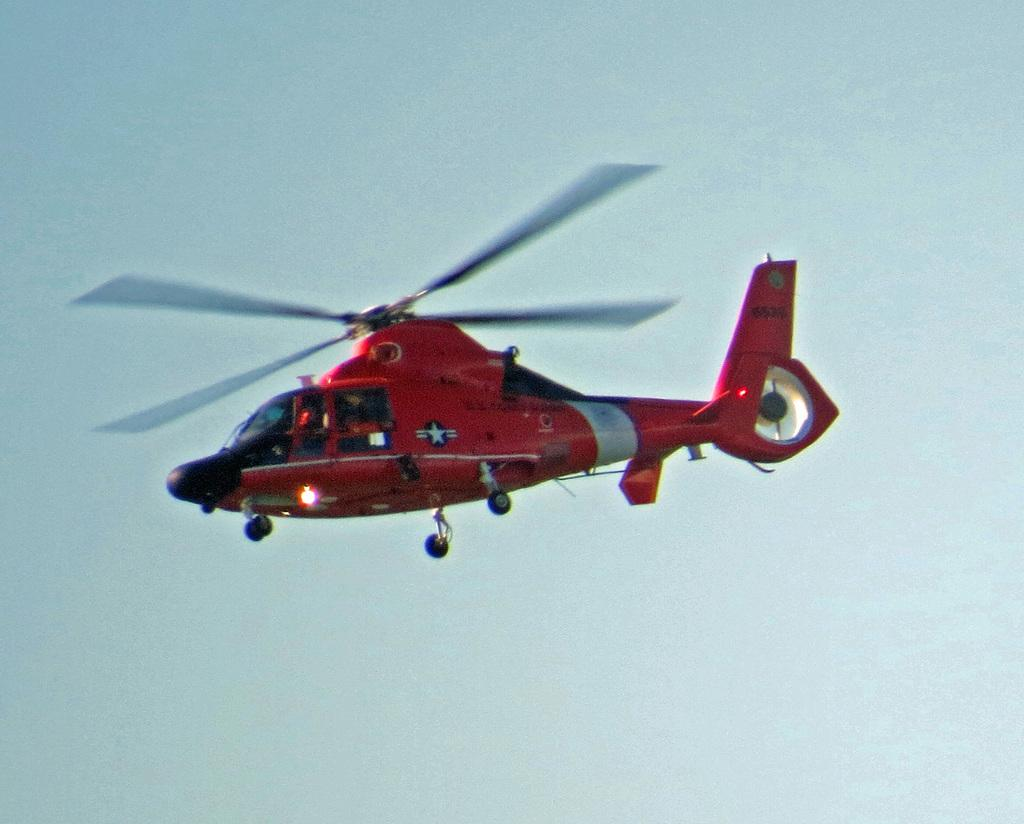What type of vehicle is in the image? There is a red helicopter in the image. What is the helicopter doing in the image? The helicopter is flying in the air. In which direction is the helicopter moving? The helicopter is moving towards the left side. What is visible at the top of the image? The sky is visible at the top of the image. Who is the porter responsible for carrying the helicopter in the image? There is no porter present in the image, and helicopters do not require human assistance for flight. How many errors can be seen in the image? There are no errors visible in the image; it is a clear depiction of a red helicopter flying in the air. 